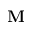<formula> <loc_0><loc_0><loc_500><loc_500>M</formula> 